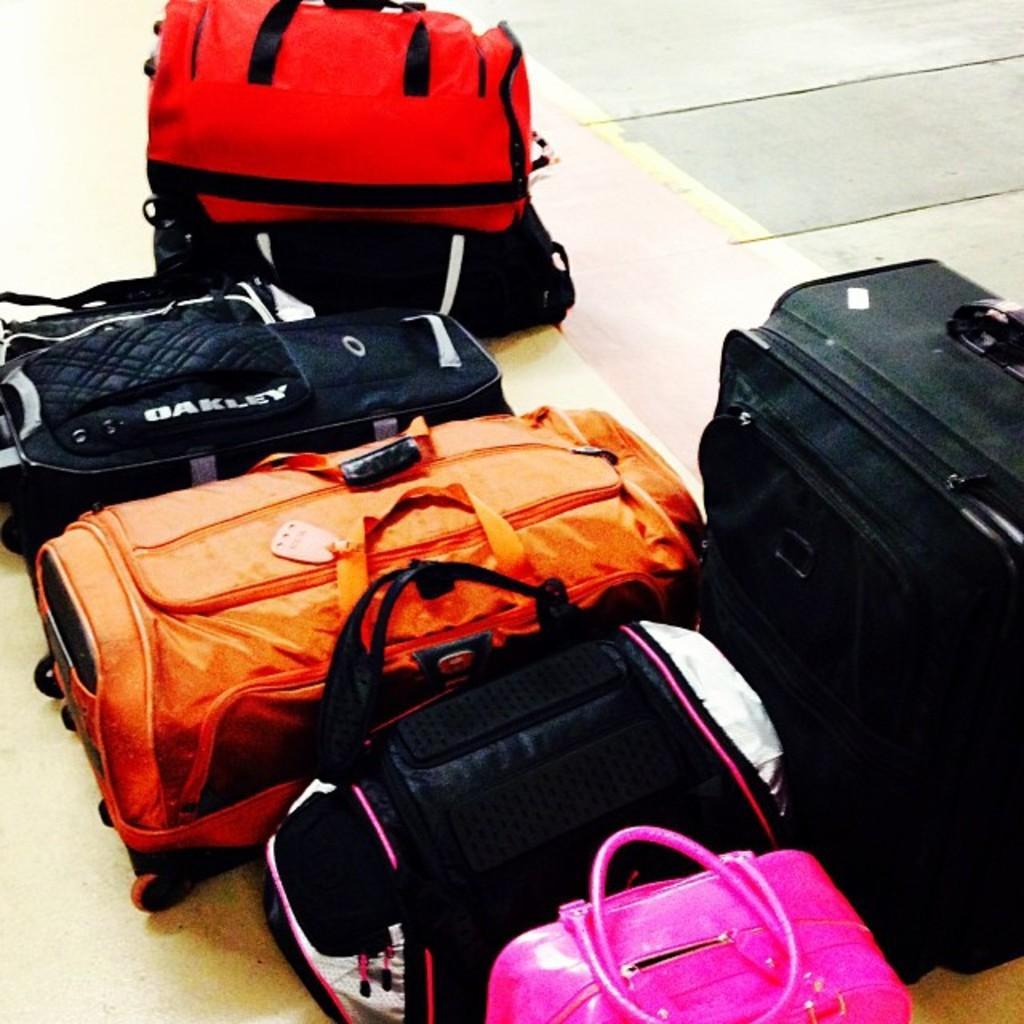How would you summarize this image in a sentence or two? In this image I can see many bags on the floor. 